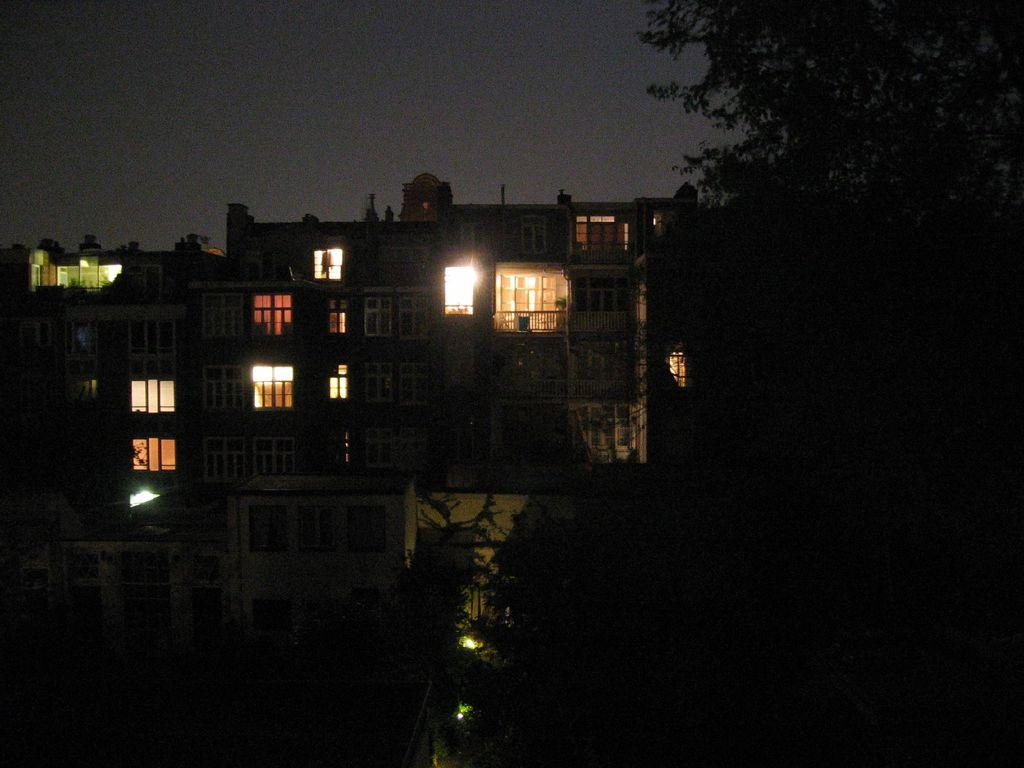What type of structures can be seen in the image? There are buildings in the image. What else is visible in the image besides the buildings? There are lights and trees in the image. Can you tell me where the library is located in the image? There is no library mentioned or visible in the image. How many quarters can be seen in the image? There are no quarters present in the image. 